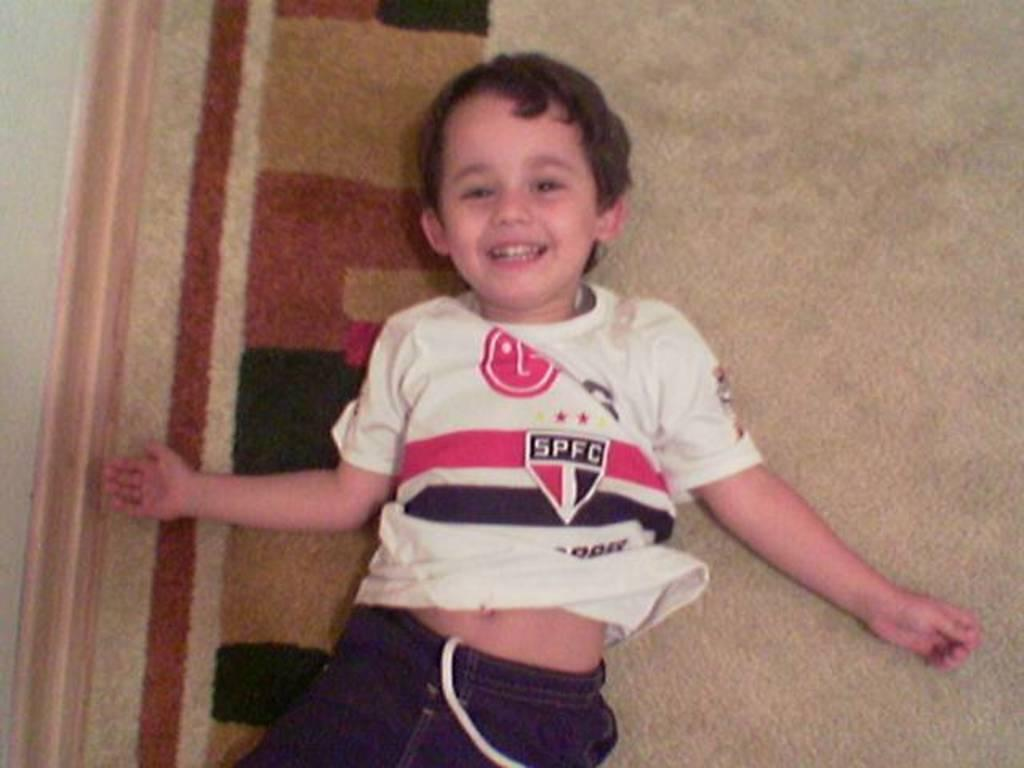<image>
Describe the image concisely. The happy little boy in the picture supports SPFC. 